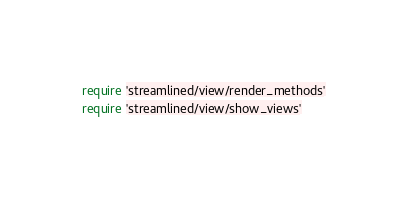<code> <loc_0><loc_0><loc_500><loc_500><_Ruby_>require 'streamlined/view/render_methods'
require 'streamlined/view/show_views'</code> 